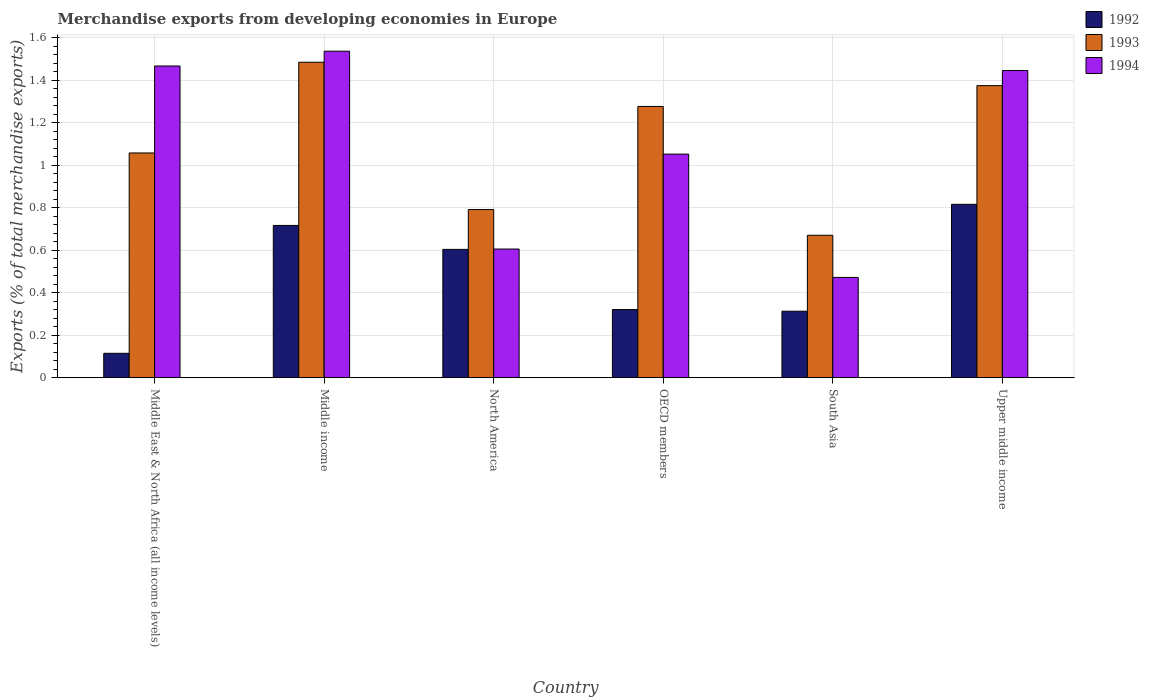How many different coloured bars are there?
Your response must be concise. 3. Are the number of bars on each tick of the X-axis equal?
Make the answer very short. Yes. How many bars are there on the 3rd tick from the left?
Provide a succinct answer. 3. How many bars are there on the 4th tick from the right?
Make the answer very short. 3. In how many cases, is the number of bars for a given country not equal to the number of legend labels?
Your answer should be compact. 0. What is the percentage of total merchandise exports in 1992 in Middle income?
Provide a short and direct response. 0.72. Across all countries, what is the maximum percentage of total merchandise exports in 1994?
Offer a very short reply. 1.54. Across all countries, what is the minimum percentage of total merchandise exports in 1993?
Make the answer very short. 0.67. In which country was the percentage of total merchandise exports in 1993 minimum?
Offer a terse response. South Asia. What is the total percentage of total merchandise exports in 1992 in the graph?
Make the answer very short. 2.88. What is the difference between the percentage of total merchandise exports in 1993 in North America and that in OECD members?
Your answer should be compact. -0.49. What is the difference between the percentage of total merchandise exports in 1992 in Middle income and the percentage of total merchandise exports in 1994 in South Asia?
Keep it short and to the point. 0.24. What is the average percentage of total merchandise exports in 1994 per country?
Make the answer very short. 1.1. What is the difference between the percentage of total merchandise exports of/in 1994 and percentage of total merchandise exports of/in 1992 in Upper middle income?
Provide a succinct answer. 0.63. In how many countries, is the percentage of total merchandise exports in 1992 greater than 0.04 %?
Give a very brief answer. 6. What is the ratio of the percentage of total merchandise exports in 1993 in Middle East & North Africa (all income levels) to that in Upper middle income?
Your response must be concise. 0.77. Is the difference between the percentage of total merchandise exports in 1994 in North America and OECD members greater than the difference between the percentage of total merchandise exports in 1992 in North America and OECD members?
Provide a succinct answer. No. What is the difference between the highest and the second highest percentage of total merchandise exports in 1993?
Offer a very short reply. 0.21. What is the difference between the highest and the lowest percentage of total merchandise exports in 1993?
Make the answer very short. 0.81. In how many countries, is the percentage of total merchandise exports in 1992 greater than the average percentage of total merchandise exports in 1992 taken over all countries?
Your answer should be very brief. 3. What does the 3rd bar from the right in Upper middle income represents?
Your response must be concise. 1992. Are all the bars in the graph horizontal?
Ensure brevity in your answer.  No. What is the difference between two consecutive major ticks on the Y-axis?
Ensure brevity in your answer.  0.2. Are the values on the major ticks of Y-axis written in scientific E-notation?
Provide a short and direct response. No. Does the graph contain any zero values?
Your answer should be compact. No. What is the title of the graph?
Your answer should be compact. Merchandise exports from developing economies in Europe. Does "1988" appear as one of the legend labels in the graph?
Your answer should be compact. No. What is the label or title of the X-axis?
Your answer should be compact. Country. What is the label or title of the Y-axis?
Your answer should be very brief. Exports (% of total merchandise exports). What is the Exports (% of total merchandise exports) of 1992 in Middle East & North Africa (all income levels)?
Your response must be concise. 0.11. What is the Exports (% of total merchandise exports) of 1993 in Middle East & North Africa (all income levels)?
Provide a short and direct response. 1.06. What is the Exports (% of total merchandise exports) of 1994 in Middle East & North Africa (all income levels)?
Offer a terse response. 1.47. What is the Exports (% of total merchandise exports) in 1992 in Middle income?
Your answer should be compact. 0.72. What is the Exports (% of total merchandise exports) in 1993 in Middle income?
Offer a very short reply. 1.48. What is the Exports (% of total merchandise exports) in 1994 in Middle income?
Your answer should be very brief. 1.54. What is the Exports (% of total merchandise exports) of 1992 in North America?
Ensure brevity in your answer.  0.6. What is the Exports (% of total merchandise exports) of 1993 in North America?
Provide a short and direct response. 0.79. What is the Exports (% of total merchandise exports) in 1994 in North America?
Ensure brevity in your answer.  0.61. What is the Exports (% of total merchandise exports) of 1992 in OECD members?
Offer a terse response. 0.32. What is the Exports (% of total merchandise exports) of 1993 in OECD members?
Your answer should be very brief. 1.28. What is the Exports (% of total merchandise exports) in 1994 in OECD members?
Give a very brief answer. 1.05. What is the Exports (% of total merchandise exports) in 1992 in South Asia?
Ensure brevity in your answer.  0.31. What is the Exports (% of total merchandise exports) in 1993 in South Asia?
Your response must be concise. 0.67. What is the Exports (% of total merchandise exports) in 1994 in South Asia?
Ensure brevity in your answer.  0.47. What is the Exports (% of total merchandise exports) in 1992 in Upper middle income?
Your response must be concise. 0.82. What is the Exports (% of total merchandise exports) of 1993 in Upper middle income?
Ensure brevity in your answer.  1.37. What is the Exports (% of total merchandise exports) of 1994 in Upper middle income?
Ensure brevity in your answer.  1.45. Across all countries, what is the maximum Exports (% of total merchandise exports) in 1992?
Keep it short and to the point. 0.82. Across all countries, what is the maximum Exports (% of total merchandise exports) of 1993?
Keep it short and to the point. 1.48. Across all countries, what is the maximum Exports (% of total merchandise exports) of 1994?
Ensure brevity in your answer.  1.54. Across all countries, what is the minimum Exports (% of total merchandise exports) in 1992?
Ensure brevity in your answer.  0.11. Across all countries, what is the minimum Exports (% of total merchandise exports) of 1993?
Your response must be concise. 0.67. Across all countries, what is the minimum Exports (% of total merchandise exports) in 1994?
Offer a terse response. 0.47. What is the total Exports (% of total merchandise exports) in 1992 in the graph?
Make the answer very short. 2.88. What is the total Exports (% of total merchandise exports) in 1993 in the graph?
Offer a very short reply. 6.66. What is the total Exports (% of total merchandise exports) in 1994 in the graph?
Provide a succinct answer. 6.58. What is the difference between the Exports (% of total merchandise exports) in 1992 in Middle East & North Africa (all income levels) and that in Middle income?
Offer a terse response. -0.6. What is the difference between the Exports (% of total merchandise exports) in 1993 in Middle East & North Africa (all income levels) and that in Middle income?
Make the answer very short. -0.43. What is the difference between the Exports (% of total merchandise exports) of 1994 in Middle East & North Africa (all income levels) and that in Middle income?
Provide a succinct answer. -0.07. What is the difference between the Exports (% of total merchandise exports) of 1992 in Middle East & North Africa (all income levels) and that in North America?
Your answer should be compact. -0.49. What is the difference between the Exports (% of total merchandise exports) of 1993 in Middle East & North Africa (all income levels) and that in North America?
Your response must be concise. 0.27. What is the difference between the Exports (% of total merchandise exports) of 1994 in Middle East & North Africa (all income levels) and that in North America?
Ensure brevity in your answer.  0.86. What is the difference between the Exports (% of total merchandise exports) in 1992 in Middle East & North Africa (all income levels) and that in OECD members?
Keep it short and to the point. -0.21. What is the difference between the Exports (% of total merchandise exports) of 1993 in Middle East & North Africa (all income levels) and that in OECD members?
Give a very brief answer. -0.22. What is the difference between the Exports (% of total merchandise exports) in 1994 in Middle East & North Africa (all income levels) and that in OECD members?
Your answer should be very brief. 0.41. What is the difference between the Exports (% of total merchandise exports) in 1992 in Middle East & North Africa (all income levels) and that in South Asia?
Offer a terse response. -0.2. What is the difference between the Exports (% of total merchandise exports) in 1993 in Middle East & North Africa (all income levels) and that in South Asia?
Your answer should be very brief. 0.39. What is the difference between the Exports (% of total merchandise exports) of 1994 in Middle East & North Africa (all income levels) and that in South Asia?
Give a very brief answer. 1. What is the difference between the Exports (% of total merchandise exports) of 1992 in Middle East & North Africa (all income levels) and that in Upper middle income?
Give a very brief answer. -0.7. What is the difference between the Exports (% of total merchandise exports) of 1993 in Middle East & North Africa (all income levels) and that in Upper middle income?
Offer a very short reply. -0.32. What is the difference between the Exports (% of total merchandise exports) of 1994 in Middle East & North Africa (all income levels) and that in Upper middle income?
Make the answer very short. 0.02. What is the difference between the Exports (% of total merchandise exports) of 1992 in Middle income and that in North America?
Your response must be concise. 0.11. What is the difference between the Exports (% of total merchandise exports) in 1993 in Middle income and that in North America?
Provide a short and direct response. 0.69. What is the difference between the Exports (% of total merchandise exports) of 1994 in Middle income and that in North America?
Ensure brevity in your answer.  0.93. What is the difference between the Exports (% of total merchandise exports) of 1992 in Middle income and that in OECD members?
Offer a terse response. 0.4. What is the difference between the Exports (% of total merchandise exports) in 1993 in Middle income and that in OECD members?
Provide a short and direct response. 0.21. What is the difference between the Exports (% of total merchandise exports) in 1994 in Middle income and that in OECD members?
Offer a very short reply. 0.48. What is the difference between the Exports (% of total merchandise exports) of 1992 in Middle income and that in South Asia?
Provide a succinct answer. 0.4. What is the difference between the Exports (% of total merchandise exports) of 1993 in Middle income and that in South Asia?
Keep it short and to the point. 0.81. What is the difference between the Exports (% of total merchandise exports) in 1994 in Middle income and that in South Asia?
Your response must be concise. 1.06. What is the difference between the Exports (% of total merchandise exports) of 1992 in Middle income and that in Upper middle income?
Offer a terse response. -0.1. What is the difference between the Exports (% of total merchandise exports) in 1993 in Middle income and that in Upper middle income?
Provide a short and direct response. 0.11. What is the difference between the Exports (% of total merchandise exports) of 1994 in Middle income and that in Upper middle income?
Give a very brief answer. 0.09. What is the difference between the Exports (% of total merchandise exports) of 1992 in North America and that in OECD members?
Your answer should be compact. 0.28. What is the difference between the Exports (% of total merchandise exports) in 1993 in North America and that in OECD members?
Keep it short and to the point. -0.49. What is the difference between the Exports (% of total merchandise exports) in 1994 in North America and that in OECD members?
Provide a short and direct response. -0.45. What is the difference between the Exports (% of total merchandise exports) of 1992 in North America and that in South Asia?
Give a very brief answer. 0.29. What is the difference between the Exports (% of total merchandise exports) of 1993 in North America and that in South Asia?
Your answer should be very brief. 0.12. What is the difference between the Exports (% of total merchandise exports) of 1994 in North America and that in South Asia?
Give a very brief answer. 0.13. What is the difference between the Exports (% of total merchandise exports) of 1992 in North America and that in Upper middle income?
Make the answer very short. -0.21. What is the difference between the Exports (% of total merchandise exports) of 1993 in North America and that in Upper middle income?
Offer a very short reply. -0.58. What is the difference between the Exports (% of total merchandise exports) of 1994 in North America and that in Upper middle income?
Provide a succinct answer. -0.84. What is the difference between the Exports (% of total merchandise exports) of 1992 in OECD members and that in South Asia?
Ensure brevity in your answer.  0.01. What is the difference between the Exports (% of total merchandise exports) of 1993 in OECD members and that in South Asia?
Give a very brief answer. 0.61. What is the difference between the Exports (% of total merchandise exports) of 1994 in OECD members and that in South Asia?
Keep it short and to the point. 0.58. What is the difference between the Exports (% of total merchandise exports) of 1992 in OECD members and that in Upper middle income?
Your response must be concise. -0.5. What is the difference between the Exports (% of total merchandise exports) in 1993 in OECD members and that in Upper middle income?
Offer a terse response. -0.1. What is the difference between the Exports (% of total merchandise exports) of 1994 in OECD members and that in Upper middle income?
Provide a succinct answer. -0.39. What is the difference between the Exports (% of total merchandise exports) of 1992 in South Asia and that in Upper middle income?
Your answer should be compact. -0.5. What is the difference between the Exports (% of total merchandise exports) in 1993 in South Asia and that in Upper middle income?
Give a very brief answer. -0.7. What is the difference between the Exports (% of total merchandise exports) in 1994 in South Asia and that in Upper middle income?
Ensure brevity in your answer.  -0.97. What is the difference between the Exports (% of total merchandise exports) in 1992 in Middle East & North Africa (all income levels) and the Exports (% of total merchandise exports) in 1993 in Middle income?
Your answer should be very brief. -1.37. What is the difference between the Exports (% of total merchandise exports) in 1992 in Middle East & North Africa (all income levels) and the Exports (% of total merchandise exports) in 1994 in Middle income?
Make the answer very short. -1.42. What is the difference between the Exports (% of total merchandise exports) in 1993 in Middle East & North Africa (all income levels) and the Exports (% of total merchandise exports) in 1994 in Middle income?
Your answer should be very brief. -0.48. What is the difference between the Exports (% of total merchandise exports) in 1992 in Middle East & North Africa (all income levels) and the Exports (% of total merchandise exports) in 1993 in North America?
Make the answer very short. -0.68. What is the difference between the Exports (% of total merchandise exports) of 1992 in Middle East & North Africa (all income levels) and the Exports (% of total merchandise exports) of 1994 in North America?
Ensure brevity in your answer.  -0.49. What is the difference between the Exports (% of total merchandise exports) of 1993 in Middle East & North Africa (all income levels) and the Exports (% of total merchandise exports) of 1994 in North America?
Make the answer very short. 0.45. What is the difference between the Exports (% of total merchandise exports) in 1992 in Middle East & North Africa (all income levels) and the Exports (% of total merchandise exports) in 1993 in OECD members?
Offer a very short reply. -1.16. What is the difference between the Exports (% of total merchandise exports) of 1992 in Middle East & North Africa (all income levels) and the Exports (% of total merchandise exports) of 1994 in OECD members?
Make the answer very short. -0.94. What is the difference between the Exports (% of total merchandise exports) of 1993 in Middle East & North Africa (all income levels) and the Exports (% of total merchandise exports) of 1994 in OECD members?
Keep it short and to the point. 0.01. What is the difference between the Exports (% of total merchandise exports) of 1992 in Middle East & North Africa (all income levels) and the Exports (% of total merchandise exports) of 1993 in South Asia?
Your response must be concise. -0.56. What is the difference between the Exports (% of total merchandise exports) in 1992 in Middle East & North Africa (all income levels) and the Exports (% of total merchandise exports) in 1994 in South Asia?
Provide a short and direct response. -0.36. What is the difference between the Exports (% of total merchandise exports) of 1993 in Middle East & North Africa (all income levels) and the Exports (% of total merchandise exports) of 1994 in South Asia?
Offer a very short reply. 0.59. What is the difference between the Exports (% of total merchandise exports) of 1992 in Middle East & North Africa (all income levels) and the Exports (% of total merchandise exports) of 1993 in Upper middle income?
Make the answer very short. -1.26. What is the difference between the Exports (% of total merchandise exports) in 1992 in Middle East & North Africa (all income levels) and the Exports (% of total merchandise exports) in 1994 in Upper middle income?
Your answer should be very brief. -1.33. What is the difference between the Exports (% of total merchandise exports) in 1993 in Middle East & North Africa (all income levels) and the Exports (% of total merchandise exports) in 1994 in Upper middle income?
Make the answer very short. -0.39. What is the difference between the Exports (% of total merchandise exports) of 1992 in Middle income and the Exports (% of total merchandise exports) of 1993 in North America?
Your response must be concise. -0.07. What is the difference between the Exports (% of total merchandise exports) of 1992 in Middle income and the Exports (% of total merchandise exports) of 1994 in North America?
Offer a very short reply. 0.11. What is the difference between the Exports (% of total merchandise exports) of 1993 in Middle income and the Exports (% of total merchandise exports) of 1994 in North America?
Offer a very short reply. 0.88. What is the difference between the Exports (% of total merchandise exports) in 1992 in Middle income and the Exports (% of total merchandise exports) in 1993 in OECD members?
Make the answer very short. -0.56. What is the difference between the Exports (% of total merchandise exports) of 1992 in Middle income and the Exports (% of total merchandise exports) of 1994 in OECD members?
Ensure brevity in your answer.  -0.34. What is the difference between the Exports (% of total merchandise exports) in 1993 in Middle income and the Exports (% of total merchandise exports) in 1994 in OECD members?
Make the answer very short. 0.43. What is the difference between the Exports (% of total merchandise exports) of 1992 in Middle income and the Exports (% of total merchandise exports) of 1993 in South Asia?
Your answer should be compact. 0.05. What is the difference between the Exports (% of total merchandise exports) of 1992 in Middle income and the Exports (% of total merchandise exports) of 1994 in South Asia?
Make the answer very short. 0.24. What is the difference between the Exports (% of total merchandise exports) of 1993 in Middle income and the Exports (% of total merchandise exports) of 1994 in South Asia?
Offer a very short reply. 1.01. What is the difference between the Exports (% of total merchandise exports) in 1992 in Middle income and the Exports (% of total merchandise exports) in 1993 in Upper middle income?
Provide a succinct answer. -0.66. What is the difference between the Exports (% of total merchandise exports) in 1992 in Middle income and the Exports (% of total merchandise exports) in 1994 in Upper middle income?
Make the answer very short. -0.73. What is the difference between the Exports (% of total merchandise exports) of 1993 in Middle income and the Exports (% of total merchandise exports) of 1994 in Upper middle income?
Your answer should be very brief. 0.04. What is the difference between the Exports (% of total merchandise exports) in 1992 in North America and the Exports (% of total merchandise exports) in 1993 in OECD members?
Ensure brevity in your answer.  -0.67. What is the difference between the Exports (% of total merchandise exports) in 1992 in North America and the Exports (% of total merchandise exports) in 1994 in OECD members?
Your answer should be compact. -0.45. What is the difference between the Exports (% of total merchandise exports) of 1993 in North America and the Exports (% of total merchandise exports) of 1994 in OECD members?
Make the answer very short. -0.26. What is the difference between the Exports (% of total merchandise exports) in 1992 in North America and the Exports (% of total merchandise exports) in 1993 in South Asia?
Keep it short and to the point. -0.07. What is the difference between the Exports (% of total merchandise exports) of 1992 in North America and the Exports (% of total merchandise exports) of 1994 in South Asia?
Provide a short and direct response. 0.13. What is the difference between the Exports (% of total merchandise exports) of 1993 in North America and the Exports (% of total merchandise exports) of 1994 in South Asia?
Your answer should be compact. 0.32. What is the difference between the Exports (% of total merchandise exports) of 1992 in North America and the Exports (% of total merchandise exports) of 1993 in Upper middle income?
Provide a succinct answer. -0.77. What is the difference between the Exports (% of total merchandise exports) in 1992 in North America and the Exports (% of total merchandise exports) in 1994 in Upper middle income?
Your response must be concise. -0.84. What is the difference between the Exports (% of total merchandise exports) of 1993 in North America and the Exports (% of total merchandise exports) of 1994 in Upper middle income?
Offer a very short reply. -0.65. What is the difference between the Exports (% of total merchandise exports) in 1992 in OECD members and the Exports (% of total merchandise exports) in 1993 in South Asia?
Offer a very short reply. -0.35. What is the difference between the Exports (% of total merchandise exports) of 1992 in OECD members and the Exports (% of total merchandise exports) of 1994 in South Asia?
Your answer should be compact. -0.15. What is the difference between the Exports (% of total merchandise exports) of 1993 in OECD members and the Exports (% of total merchandise exports) of 1994 in South Asia?
Your answer should be very brief. 0.8. What is the difference between the Exports (% of total merchandise exports) of 1992 in OECD members and the Exports (% of total merchandise exports) of 1993 in Upper middle income?
Your response must be concise. -1.05. What is the difference between the Exports (% of total merchandise exports) in 1992 in OECD members and the Exports (% of total merchandise exports) in 1994 in Upper middle income?
Make the answer very short. -1.12. What is the difference between the Exports (% of total merchandise exports) of 1993 in OECD members and the Exports (% of total merchandise exports) of 1994 in Upper middle income?
Keep it short and to the point. -0.17. What is the difference between the Exports (% of total merchandise exports) of 1992 in South Asia and the Exports (% of total merchandise exports) of 1993 in Upper middle income?
Provide a succinct answer. -1.06. What is the difference between the Exports (% of total merchandise exports) in 1992 in South Asia and the Exports (% of total merchandise exports) in 1994 in Upper middle income?
Offer a terse response. -1.13. What is the difference between the Exports (% of total merchandise exports) of 1993 in South Asia and the Exports (% of total merchandise exports) of 1994 in Upper middle income?
Make the answer very short. -0.78. What is the average Exports (% of total merchandise exports) of 1992 per country?
Provide a short and direct response. 0.48. What is the average Exports (% of total merchandise exports) in 1993 per country?
Keep it short and to the point. 1.11. What is the average Exports (% of total merchandise exports) of 1994 per country?
Your response must be concise. 1.1. What is the difference between the Exports (% of total merchandise exports) in 1992 and Exports (% of total merchandise exports) in 1993 in Middle East & North Africa (all income levels)?
Your answer should be very brief. -0.94. What is the difference between the Exports (% of total merchandise exports) of 1992 and Exports (% of total merchandise exports) of 1994 in Middle East & North Africa (all income levels)?
Your answer should be compact. -1.35. What is the difference between the Exports (% of total merchandise exports) in 1993 and Exports (% of total merchandise exports) in 1994 in Middle East & North Africa (all income levels)?
Ensure brevity in your answer.  -0.41. What is the difference between the Exports (% of total merchandise exports) in 1992 and Exports (% of total merchandise exports) in 1993 in Middle income?
Your response must be concise. -0.77. What is the difference between the Exports (% of total merchandise exports) in 1992 and Exports (% of total merchandise exports) in 1994 in Middle income?
Your answer should be very brief. -0.82. What is the difference between the Exports (% of total merchandise exports) of 1993 and Exports (% of total merchandise exports) of 1994 in Middle income?
Keep it short and to the point. -0.05. What is the difference between the Exports (% of total merchandise exports) of 1992 and Exports (% of total merchandise exports) of 1993 in North America?
Offer a terse response. -0.19. What is the difference between the Exports (% of total merchandise exports) in 1992 and Exports (% of total merchandise exports) in 1994 in North America?
Your response must be concise. -0. What is the difference between the Exports (% of total merchandise exports) in 1993 and Exports (% of total merchandise exports) in 1994 in North America?
Keep it short and to the point. 0.19. What is the difference between the Exports (% of total merchandise exports) of 1992 and Exports (% of total merchandise exports) of 1993 in OECD members?
Your response must be concise. -0.96. What is the difference between the Exports (% of total merchandise exports) in 1992 and Exports (% of total merchandise exports) in 1994 in OECD members?
Provide a succinct answer. -0.73. What is the difference between the Exports (% of total merchandise exports) in 1993 and Exports (% of total merchandise exports) in 1994 in OECD members?
Your response must be concise. 0.22. What is the difference between the Exports (% of total merchandise exports) of 1992 and Exports (% of total merchandise exports) of 1993 in South Asia?
Offer a very short reply. -0.36. What is the difference between the Exports (% of total merchandise exports) of 1992 and Exports (% of total merchandise exports) of 1994 in South Asia?
Your answer should be very brief. -0.16. What is the difference between the Exports (% of total merchandise exports) in 1993 and Exports (% of total merchandise exports) in 1994 in South Asia?
Ensure brevity in your answer.  0.2. What is the difference between the Exports (% of total merchandise exports) in 1992 and Exports (% of total merchandise exports) in 1993 in Upper middle income?
Provide a succinct answer. -0.56. What is the difference between the Exports (% of total merchandise exports) in 1992 and Exports (% of total merchandise exports) in 1994 in Upper middle income?
Offer a terse response. -0.63. What is the difference between the Exports (% of total merchandise exports) of 1993 and Exports (% of total merchandise exports) of 1994 in Upper middle income?
Your response must be concise. -0.07. What is the ratio of the Exports (% of total merchandise exports) in 1992 in Middle East & North Africa (all income levels) to that in Middle income?
Your response must be concise. 0.16. What is the ratio of the Exports (% of total merchandise exports) of 1993 in Middle East & North Africa (all income levels) to that in Middle income?
Your response must be concise. 0.71. What is the ratio of the Exports (% of total merchandise exports) of 1994 in Middle East & North Africa (all income levels) to that in Middle income?
Make the answer very short. 0.95. What is the ratio of the Exports (% of total merchandise exports) of 1992 in Middle East & North Africa (all income levels) to that in North America?
Your response must be concise. 0.19. What is the ratio of the Exports (% of total merchandise exports) in 1993 in Middle East & North Africa (all income levels) to that in North America?
Keep it short and to the point. 1.34. What is the ratio of the Exports (% of total merchandise exports) of 1994 in Middle East & North Africa (all income levels) to that in North America?
Give a very brief answer. 2.42. What is the ratio of the Exports (% of total merchandise exports) in 1992 in Middle East & North Africa (all income levels) to that in OECD members?
Offer a terse response. 0.36. What is the ratio of the Exports (% of total merchandise exports) of 1993 in Middle East & North Africa (all income levels) to that in OECD members?
Make the answer very short. 0.83. What is the ratio of the Exports (% of total merchandise exports) in 1994 in Middle East & North Africa (all income levels) to that in OECD members?
Make the answer very short. 1.39. What is the ratio of the Exports (% of total merchandise exports) in 1992 in Middle East & North Africa (all income levels) to that in South Asia?
Your response must be concise. 0.37. What is the ratio of the Exports (% of total merchandise exports) of 1993 in Middle East & North Africa (all income levels) to that in South Asia?
Offer a terse response. 1.58. What is the ratio of the Exports (% of total merchandise exports) of 1994 in Middle East & North Africa (all income levels) to that in South Asia?
Offer a very short reply. 3.11. What is the ratio of the Exports (% of total merchandise exports) of 1992 in Middle East & North Africa (all income levels) to that in Upper middle income?
Make the answer very short. 0.14. What is the ratio of the Exports (% of total merchandise exports) in 1993 in Middle East & North Africa (all income levels) to that in Upper middle income?
Your answer should be very brief. 0.77. What is the ratio of the Exports (% of total merchandise exports) in 1994 in Middle East & North Africa (all income levels) to that in Upper middle income?
Offer a very short reply. 1.01. What is the ratio of the Exports (% of total merchandise exports) in 1992 in Middle income to that in North America?
Your answer should be very brief. 1.19. What is the ratio of the Exports (% of total merchandise exports) in 1993 in Middle income to that in North America?
Your response must be concise. 1.88. What is the ratio of the Exports (% of total merchandise exports) in 1994 in Middle income to that in North America?
Ensure brevity in your answer.  2.54. What is the ratio of the Exports (% of total merchandise exports) in 1992 in Middle income to that in OECD members?
Give a very brief answer. 2.23. What is the ratio of the Exports (% of total merchandise exports) in 1993 in Middle income to that in OECD members?
Ensure brevity in your answer.  1.16. What is the ratio of the Exports (% of total merchandise exports) of 1994 in Middle income to that in OECD members?
Your answer should be compact. 1.46. What is the ratio of the Exports (% of total merchandise exports) in 1992 in Middle income to that in South Asia?
Give a very brief answer. 2.29. What is the ratio of the Exports (% of total merchandise exports) in 1993 in Middle income to that in South Asia?
Ensure brevity in your answer.  2.22. What is the ratio of the Exports (% of total merchandise exports) of 1994 in Middle income to that in South Asia?
Offer a very short reply. 3.26. What is the ratio of the Exports (% of total merchandise exports) of 1992 in Middle income to that in Upper middle income?
Offer a very short reply. 0.88. What is the ratio of the Exports (% of total merchandise exports) of 1993 in Middle income to that in Upper middle income?
Your answer should be very brief. 1.08. What is the ratio of the Exports (% of total merchandise exports) of 1994 in Middle income to that in Upper middle income?
Give a very brief answer. 1.06. What is the ratio of the Exports (% of total merchandise exports) in 1992 in North America to that in OECD members?
Your answer should be compact. 1.88. What is the ratio of the Exports (% of total merchandise exports) in 1993 in North America to that in OECD members?
Your answer should be compact. 0.62. What is the ratio of the Exports (% of total merchandise exports) in 1994 in North America to that in OECD members?
Keep it short and to the point. 0.58. What is the ratio of the Exports (% of total merchandise exports) in 1992 in North America to that in South Asia?
Provide a short and direct response. 1.93. What is the ratio of the Exports (% of total merchandise exports) of 1993 in North America to that in South Asia?
Make the answer very short. 1.18. What is the ratio of the Exports (% of total merchandise exports) of 1994 in North America to that in South Asia?
Your answer should be very brief. 1.28. What is the ratio of the Exports (% of total merchandise exports) in 1992 in North America to that in Upper middle income?
Your answer should be very brief. 0.74. What is the ratio of the Exports (% of total merchandise exports) in 1993 in North America to that in Upper middle income?
Ensure brevity in your answer.  0.58. What is the ratio of the Exports (% of total merchandise exports) in 1994 in North America to that in Upper middle income?
Your answer should be very brief. 0.42. What is the ratio of the Exports (% of total merchandise exports) of 1992 in OECD members to that in South Asia?
Keep it short and to the point. 1.03. What is the ratio of the Exports (% of total merchandise exports) of 1993 in OECD members to that in South Asia?
Keep it short and to the point. 1.9. What is the ratio of the Exports (% of total merchandise exports) in 1994 in OECD members to that in South Asia?
Ensure brevity in your answer.  2.23. What is the ratio of the Exports (% of total merchandise exports) of 1992 in OECD members to that in Upper middle income?
Give a very brief answer. 0.39. What is the ratio of the Exports (% of total merchandise exports) of 1993 in OECD members to that in Upper middle income?
Ensure brevity in your answer.  0.93. What is the ratio of the Exports (% of total merchandise exports) of 1994 in OECD members to that in Upper middle income?
Ensure brevity in your answer.  0.73. What is the ratio of the Exports (% of total merchandise exports) of 1992 in South Asia to that in Upper middle income?
Make the answer very short. 0.38. What is the ratio of the Exports (% of total merchandise exports) in 1993 in South Asia to that in Upper middle income?
Offer a very short reply. 0.49. What is the ratio of the Exports (% of total merchandise exports) in 1994 in South Asia to that in Upper middle income?
Your response must be concise. 0.33. What is the difference between the highest and the second highest Exports (% of total merchandise exports) of 1992?
Give a very brief answer. 0.1. What is the difference between the highest and the second highest Exports (% of total merchandise exports) in 1993?
Offer a terse response. 0.11. What is the difference between the highest and the second highest Exports (% of total merchandise exports) of 1994?
Make the answer very short. 0.07. What is the difference between the highest and the lowest Exports (% of total merchandise exports) in 1992?
Give a very brief answer. 0.7. What is the difference between the highest and the lowest Exports (% of total merchandise exports) in 1993?
Provide a short and direct response. 0.81. What is the difference between the highest and the lowest Exports (% of total merchandise exports) of 1994?
Your answer should be compact. 1.06. 